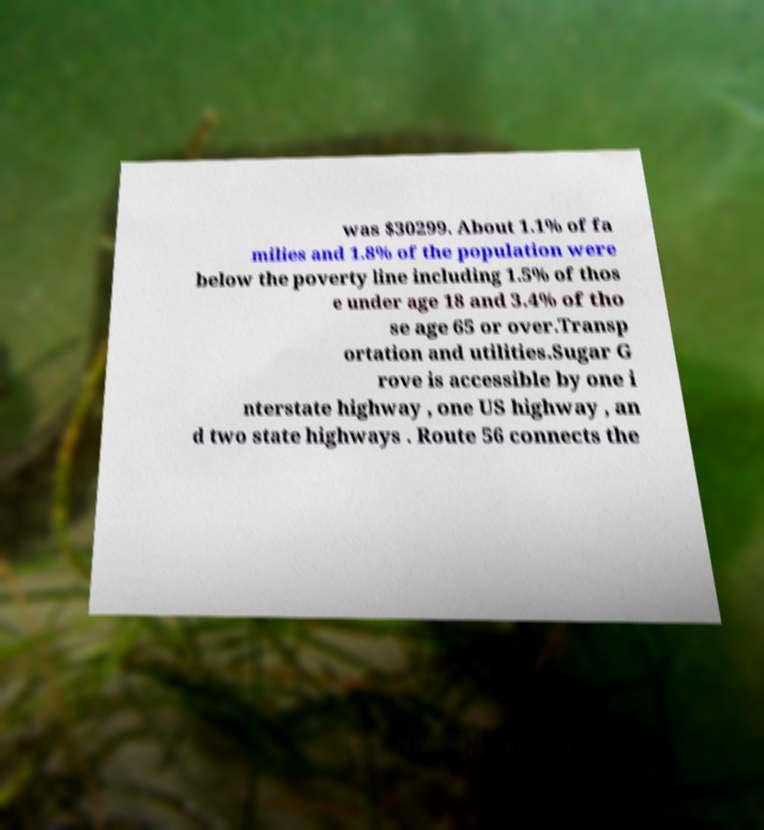Could you extract and type out the text from this image? was $30299. About 1.1% of fa milies and 1.8% of the population were below the poverty line including 1.5% of thos e under age 18 and 3.4% of tho se age 65 or over.Transp ortation and utilities.Sugar G rove is accessible by one i nterstate highway , one US highway , an d two state highways . Route 56 connects the 